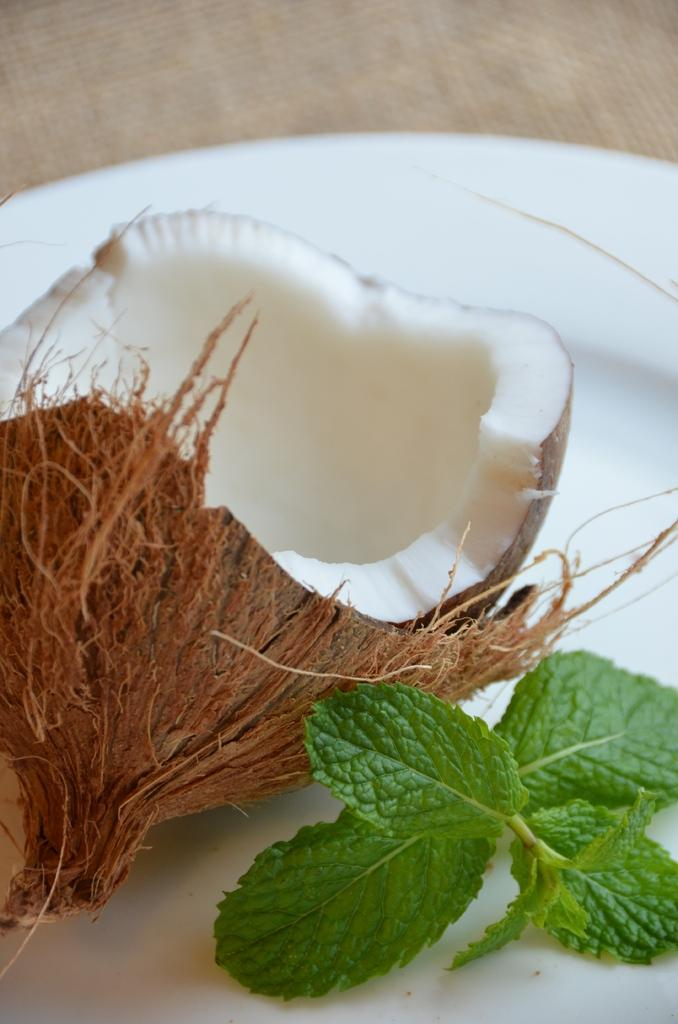What is the main object in the image? There is a coconut in the image. What other items are present with the coconut? There are mint leaves in the image. How are the coconut and mint leaves arranged? The coconut and mint leaves are on a white-colored plate. What color is the background of the image? The background of the image is brown. How many legs can be seen on the cheese in the image? A: There is no cheese present in the image, and therefore no legs can be seen on it. 